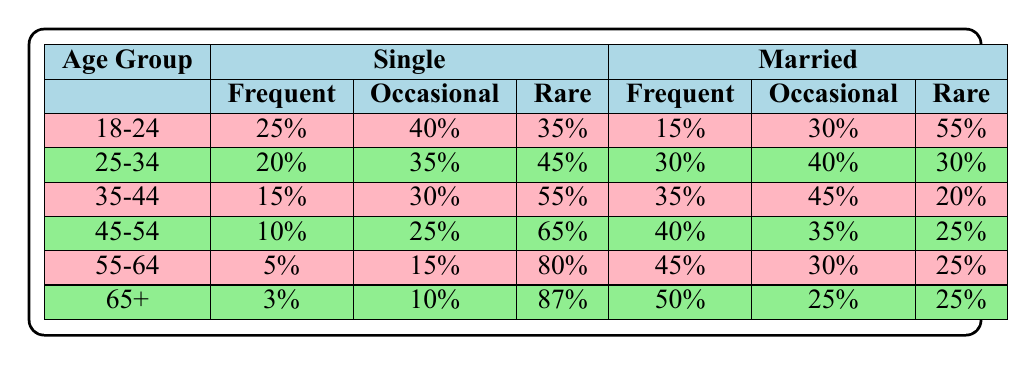What is the frequency of married individuals aged 35-44 who participate in religious activities occasionally? In the table, for the age group 35-44 under the married category, the frequency of occasional religious participation is recorded as 45%.
Answer: 45% What is the total percentage of single individuals aged 45-54 who participate in religious activities either frequently or occasionally? For the age group 45-54 in the single category, frequent participation is 10% and occasional participation is 25%. Adding both percentages gives us 10% + 25% = 35%.
Answer: 35% Is it true that the majority of individuals aged 18-24 are rare participants in religious activities? In the age group 18-24 for the single category, the rare participation level is 35%, whereas for married individuals it is 55%. Both percentages indicate that a majority of individuals in both categories are rare participants. Therefore, the statement is true.
Answer: Yes What is the difference in the percentage of frequent religious participation between married individuals aged 25-34 and single individuals aged 25-34? For the age group 25-34, the frequent participation among married individuals is 30% and for single individuals, it is 20%. The difference is calculated as 30% - 20% = 10%.
Answer: 10% Which age group has the highest percentage of single individuals who participate in religious activities consistently (frequently)? Looking at the frequent participation rates among single individuals: 18-24 (25%), 25-34 (20%), 35-44 (15%), 45-54 (10%), 55-64 (5%), and 65+ (3%). The highest is 25% in the 18-24 age group.
Answer: 18-24 What percentage of married individuals aged 65 and older rarely participate in religious activities? For individuals aged 65 and older in the married category, the rare participation percentage is recorded as 25%.
Answer: 25% 